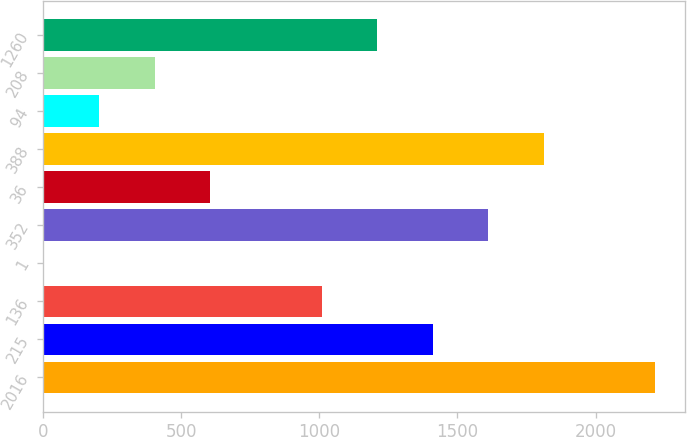Convert chart to OTSL. <chart><loc_0><loc_0><loc_500><loc_500><bar_chart><fcel>2016<fcel>215<fcel>136<fcel>1<fcel>352<fcel>36<fcel>388<fcel>94<fcel>208<fcel>1260<nl><fcel>2214<fcel>1410<fcel>1008<fcel>3<fcel>1611<fcel>606<fcel>1812<fcel>204<fcel>405<fcel>1209<nl></chart> 